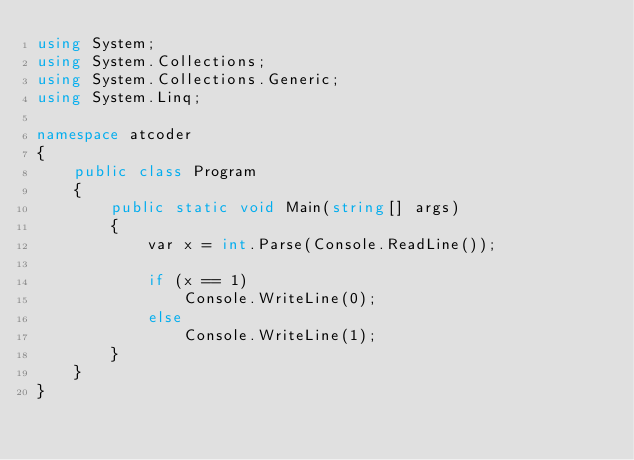<code> <loc_0><loc_0><loc_500><loc_500><_C#_>using System;
using System.Collections;
using System.Collections.Generic;
using System.Linq;

namespace atcoder
{
    public class Program
    {
        public static void Main(string[] args)
        {
            var x = int.Parse(Console.ReadLine());

            if (x == 1)
                Console.WriteLine(0);
            else
                Console.WriteLine(1);
        }
    }
}
</code> 